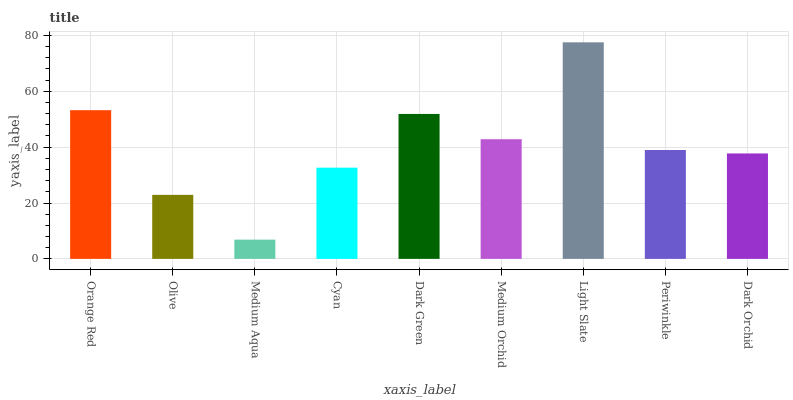Is Medium Aqua the minimum?
Answer yes or no. Yes. Is Light Slate the maximum?
Answer yes or no. Yes. Is Olive the minimum?
Answer yes or no. No. Is Olive the maximum?
Answer yes or no. No. Is Orange Red greater than Olive?
Answer yes or no. Yes. Is Olive less than Orange Red?
Answer yes or no. Yes. Is Olive greater than Orange Red?
Answer yes or no. No. Is Orange Red less than Olive?
Answer yes or no. No. Is Periwinkle the high median?
Answer yes or no. Yes. Is Periwinkle the low median?
Answer yes or no. Yes. Is Orange Red the high median?
Answer yes or no. No. Is Medium Aqua the low median?
Answer yes or no. No. 